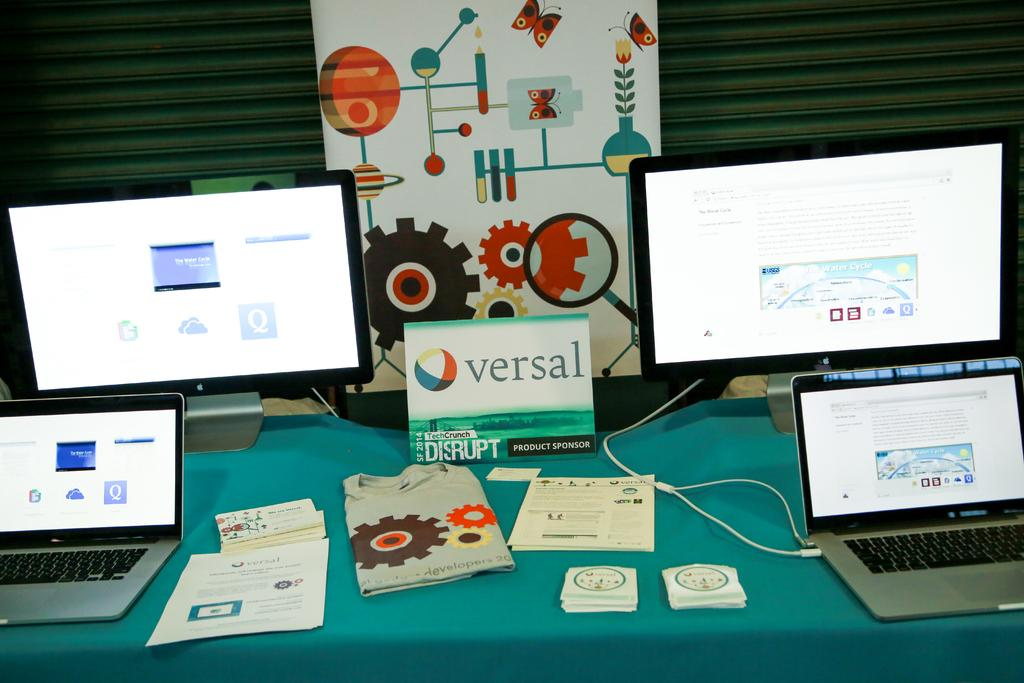Provide a one-sentence caption for the provided image. Monitors of various sizes sit on a table with a card that reads Versal in the center. 